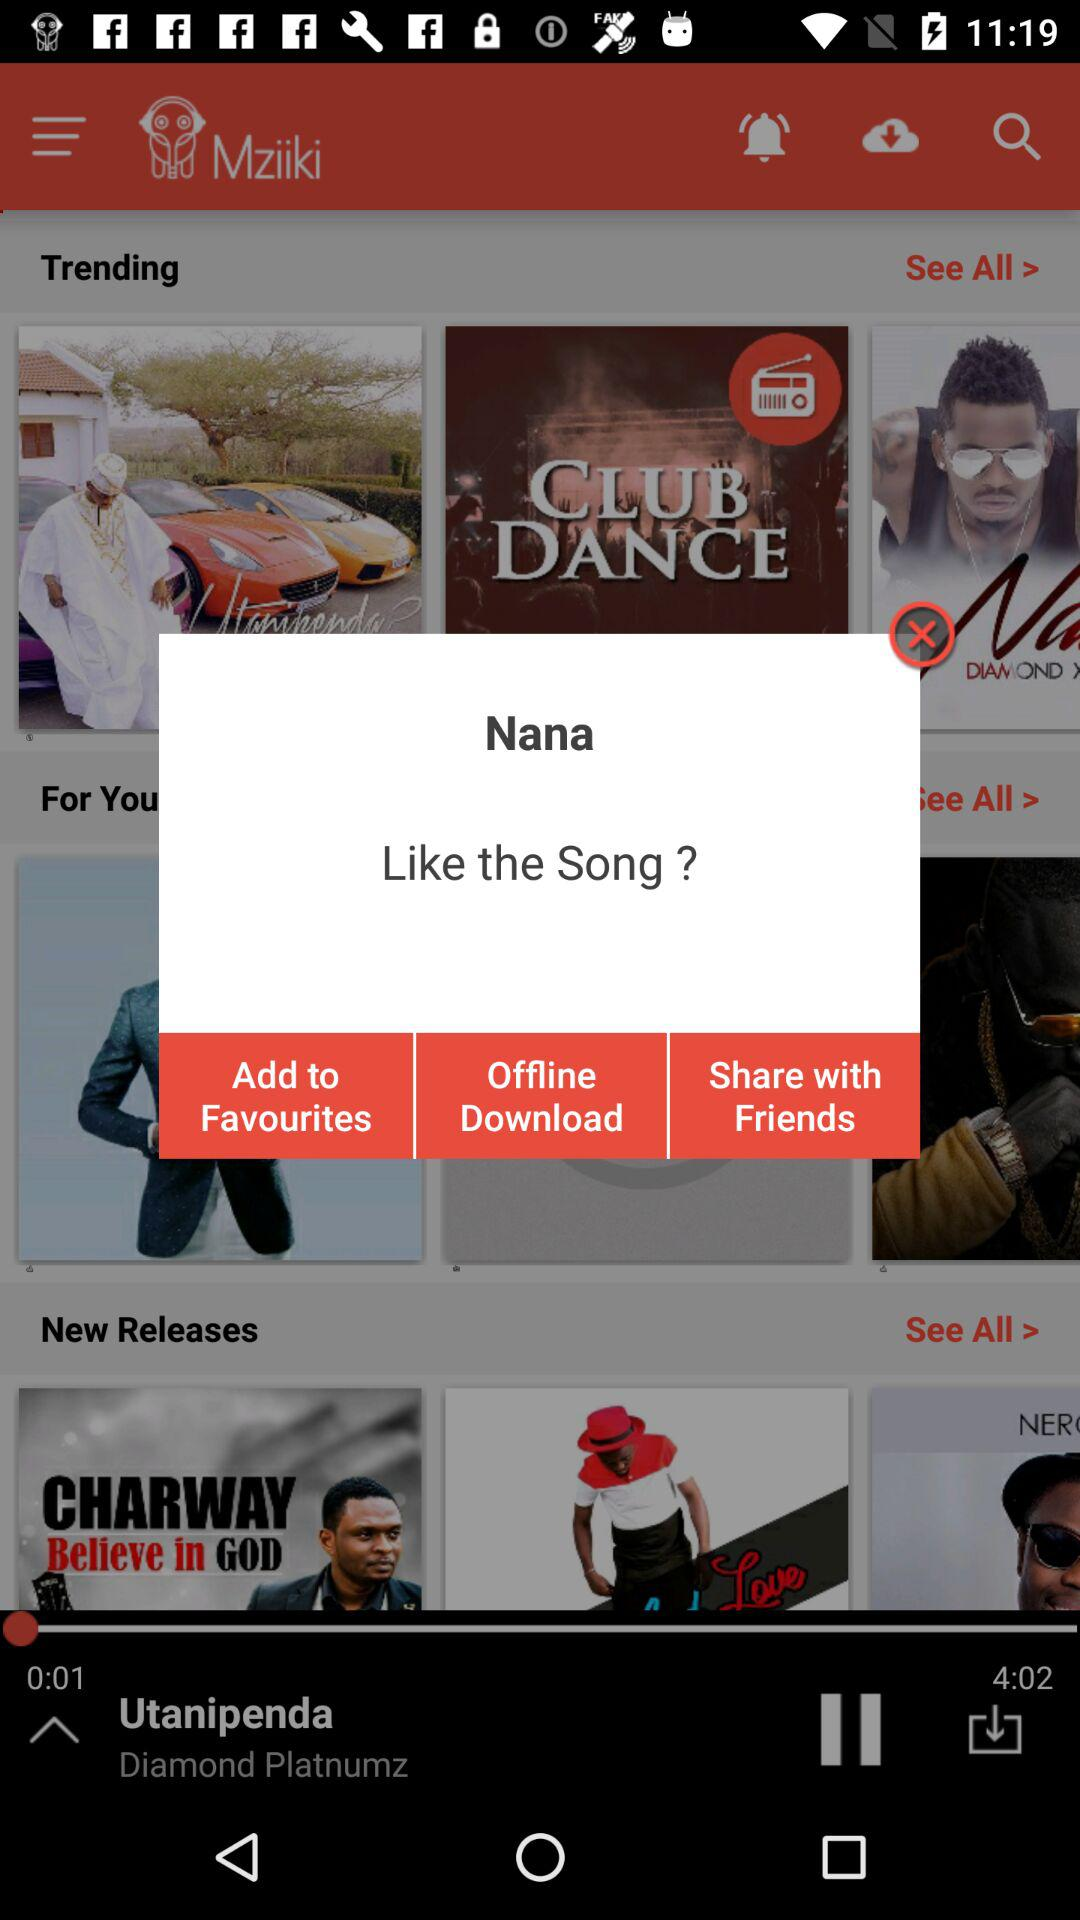What is the duration of the song? The duration of the song is 4 minutes and 2 seconds. 